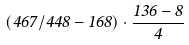<formula> <loc_0><loc_0><loc_500><loc_500>( 4 6 7 / 4 4 8 - 1 6 8 ) \cdot \frac { 1 3 6 - 8 } { 4 }</formula> 